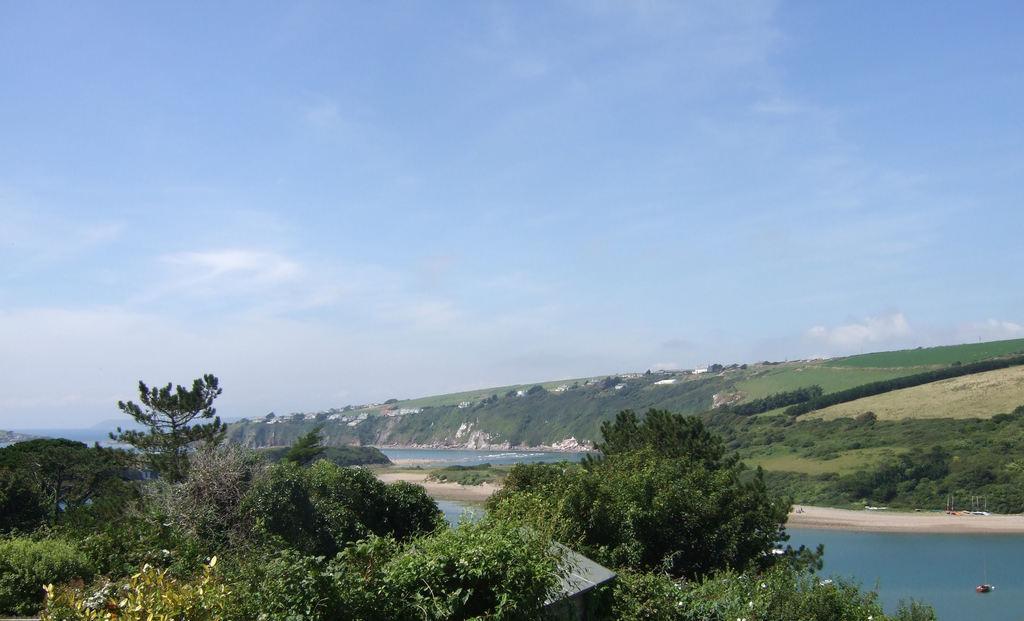Please provide a concise description of this image. In this image I see the plants, water and I see the grass over here and in the background I see the sky which is of white and blue in color. 